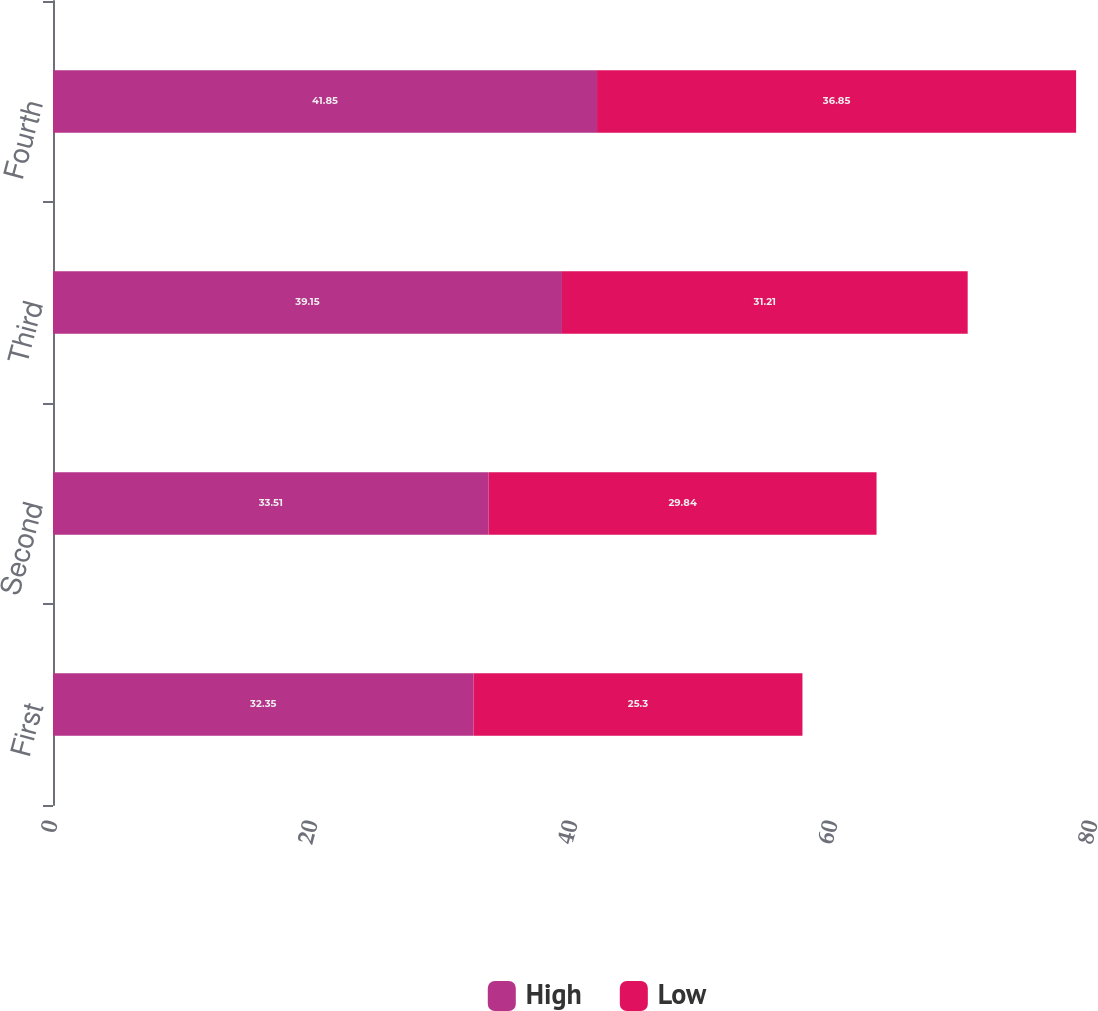Convert chart to OTSL. <chart><loc_0><loc_0><loc_500><loc_500><stacked_bar_chart><ecel><fcel>First<fcel>Second<fcel>Third<fcel>Fourth<nl><fcel>High<fcel>32.35<fcel>33.51<fcel>39.15<fcel>41.85<nl><fcel>Low<fcel>25.3<fcel>29.84<fcel>31.21<fcel>36.85<nl></chart> 